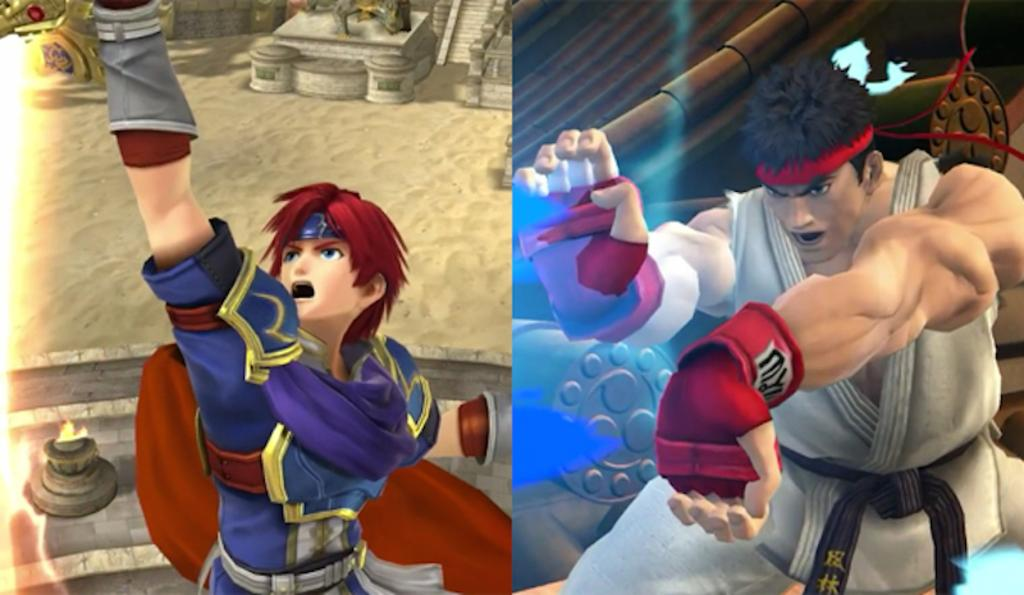What is the main subject of the image? There is a collage of two action figures in the image. What can be seen in the background of the image? There is a building and a statue in the background of the image. What type of branch can be seen growing from the cake in the image? There is no cake or branch present in the image; it features a collage of two action figures with a background containing a building and a statue. 